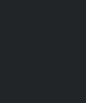<code> <loc_0><loc_0><loc_500><loc_500><_C#_>
</code> 